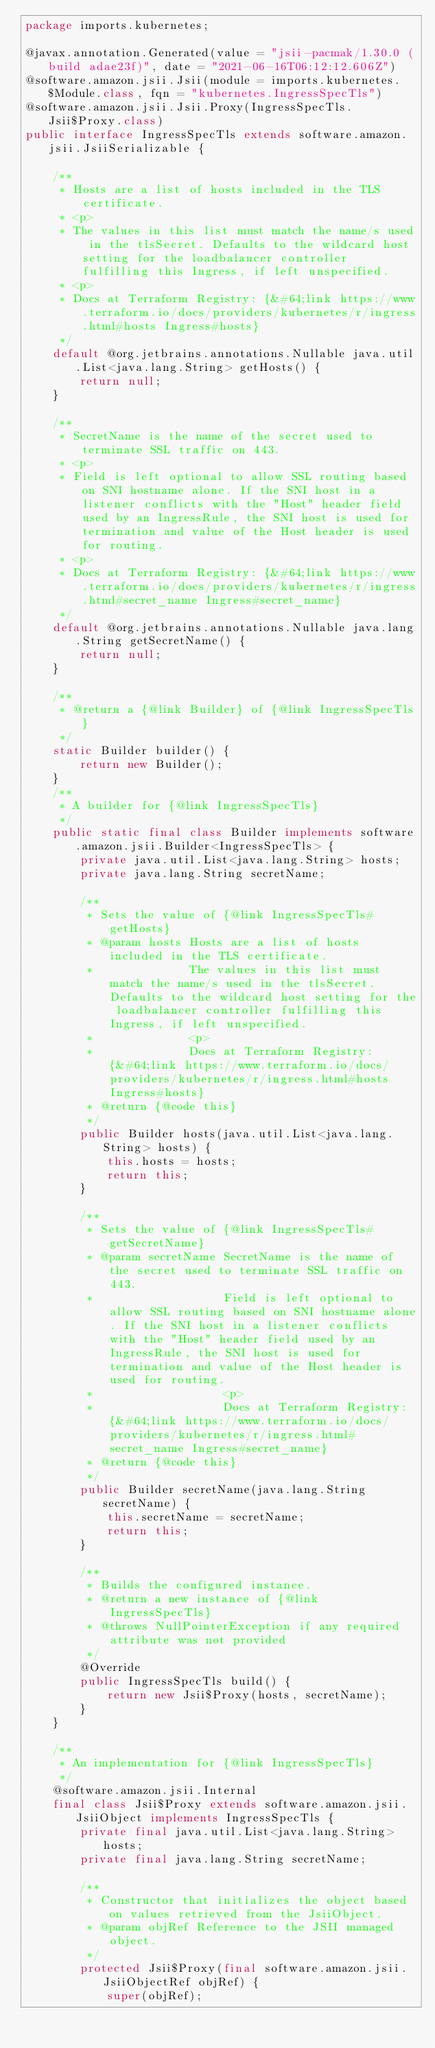Convert code to text. <code><loc_0><loc_0><loc_500><loc_500><_Java_>package imports.kubernetes;

@javax.annotation.Generated(value = "jsii-pacmak/1.30.0 (build adae23f)", date = "2021-06-16T06:12:12.606Z")
@software.amazon.jsii.Jsii(module = imports.kubernetes.$Module.class, fqn = "kubernetes.IngressSpecTls")
@software.amazon.jsii.Jsii.Proxy(IngressSpecTls.Jsii$Proxy.class)
public interface IngressSpecTls extends software.amazon.jsii.JsiiSerializable {

    /**
     * Hosts are a list of hosts included in the TLS certificate.
     * <p>
     * The values in this list must match the name/s used in the tlsSecret. Defaults to the wildcard host setting for the loadbalancer controller fulfilling this Ingress, if left unspecified.
     * <p>
     * Docs at Terraform Registry: {&#64;link https://www.terraform.io/docs/providers/kubernetes/r/ingress.html#hosts Ingress#hosts}
     */
    default @org.jetbrains.annotations.Nullable java.util.List<java.lang.String> getHosts() {
        return null;
    }

    /**
     * SecretName is the name of the secret used to terminate SSL traffic on 443.
     * <p>
     * Field is left optional to allow SSL routing based on SNI hostname alone. If the SNI host in a listener conflicts with the "Host" header field used by an IngressRule, the SNI host is used for termination and value of the Host header is used for routing.
     * <p>
     * Docs at Terraform Registry: {&#64;link https://www.terraform.io/docs/providers/kubernetes/r/ingress.html#secret_name Ingress#secret_name}
     */
    default @org.jetbrains.annotations.Nullable java.lang.String getSecretName() {
        return null;
    }

    /**
     * @return a {@link Builder} of {@link IngressSpecTls}
     */
    static Builder builder() {
        return new Builder();
    }
    /**
     * A builder for {@link IngressSpecTls}
     */
    public static final class Builder implements software.amazon.jsii.Builder<IngressSpecTls> {
        private java.util.List<java.lang.String> hosts;
        private java.lang.String secretName;

        /**
         * Sets the value of {@link IngressSpecTls#getHosts}
         * @param hosts Hosts are a list of hosts included in the TLS certificate.
         *              The values in this list must match the name/s used in the tlsSecret. Defaults to the wildcard host setting for the loadbalancer controller fulfilling this Ingress, if left unspecified.
         *              <p>
         *              Docs at Terraform Registry: {&#64;link https://www.terraform.io/docs/providers/kubernetes/r/ingress.html#hosts Ingress#hosts}
         * @return {@code this}
         */
        public Builder hosts(java.util.List<java.lang.String> hosts) {
            this.hosts = hosts;
            return this;
        }

        /**
         * Sets the value of {@link IngressSpecTls#getSecretName}
         * @param secretName SecretName is the name of the secret used to terminate SSL traffic on 443.
         *                   Field is left optional to allow SSL routing based on SNI hostname alone. If the SNI host in a listener conflicts with the "Host" header field used by an IngressRule, the SNI host is used for termination and value of the Host header is used for routing.
         *                   <p>
         *                   Docs at Terraform Registry: {&#64;link https://www.terraform.io/docs/providers/kubernetes/r/ingress.html#secret_name Ingress#secret_name}
         * @return {@code this}
         */
        public Builder secretName(java.lang.String secretName) {
            this.secretName = secretName;
            return this;
        }

        /**
         * Builds the configured instance.
         * @return a new instance of {@link IngressSpecTls}
         * @throws NullPointerException if any required attribute was not provided
         */
        @Override
        public IngressSpecTls build() {
            return new Jsii$Proxy(hosts, secretName);
        }
    }

    /**
     * An implementation for {@link IngressSpecTls}
     */
    @software.amazon.jsii.Internal
    final class Jsii$Proxy extends software.amazon.jsii.JsiiObject implements IngressSpecTls {
        private final java.util.List<java.lang.String> hosts;
        private final java.lang.String secretName;

        /**
         * Constructor that initializes the object based on values retrieved from the JsiiObject.
         * @param objRef Reference to the JSII managed object.
         */
        protected Jsii$Proxy(final software.amazon.jsii.JsiiObjectRef objRef) {
            super(objRef);</code> 